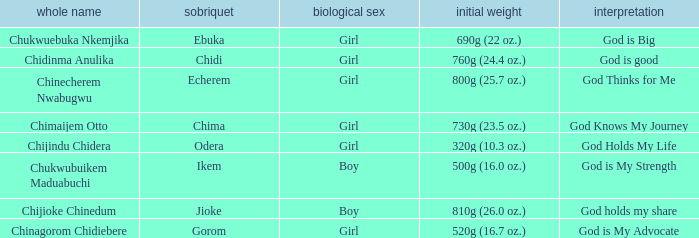Could you parse the entire table? {'header': ['whole name', 'sobriquet', 'biological sex', 'initial weight', 'interpretation'], 'rows': [['Chukwuebuka Nkemjika', 'Ebuka', 'Girl', '690g (22 oz.)', 'God is Big'], ['Chidinma Anulika', 'Chidi', 'Girl', '760g (24.4 oz.)', 'God is good'], ['Chinecherem Nwabugwu', 'Echerem', 'Girl', '800g (25.7 oz.)', 'God Thinks for Me'], ['Chimaijem Otto', 'Chima', 'Girl', '730g (23.5 oz.)', 'God Knows My Journey'], ['Chijindu Chidera', 'Odera', 'Girl', '320g (10.3 oz.)', 'God Holds My Life'], ['Chukwubuikem Maduabuchi', 'Ikem', 'Boy', '500g (16.0 oz.)', 'God is My Strength'], ['Chijioke Chinedum', 'Jioke', 'Boy', '810g (26.0 oz.)', 'God holds my share'], ['Chinagorom Chidiebere', 'Gorom', 'Girl', '520g (16.7 oz.)', 'God is My Advocate']]} What is the nickname of the boy who weighed 810g (26.0 oz.) at birth? Jioke. 